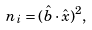<formula> <loc_0><loc_0><loc_500><loc_500>n _ { i } = ( \hat { b } \cdot \hat { x } ) ^ { 2 } ,</formula> 